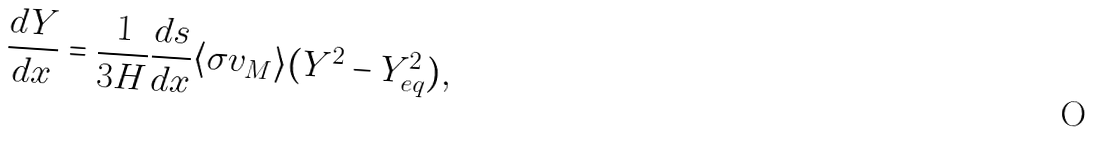<formula> <loc_0><loc_0><loc_500><loc_500>\frac { d Y } { d x } = \frac { 1 } { 3 H } \frac { d s } { d x } \langle \sigma v _ { M } \rangle ( Y ^ { 2 } - Y _ { e q } ^ { 2 } ) ,</formula> 